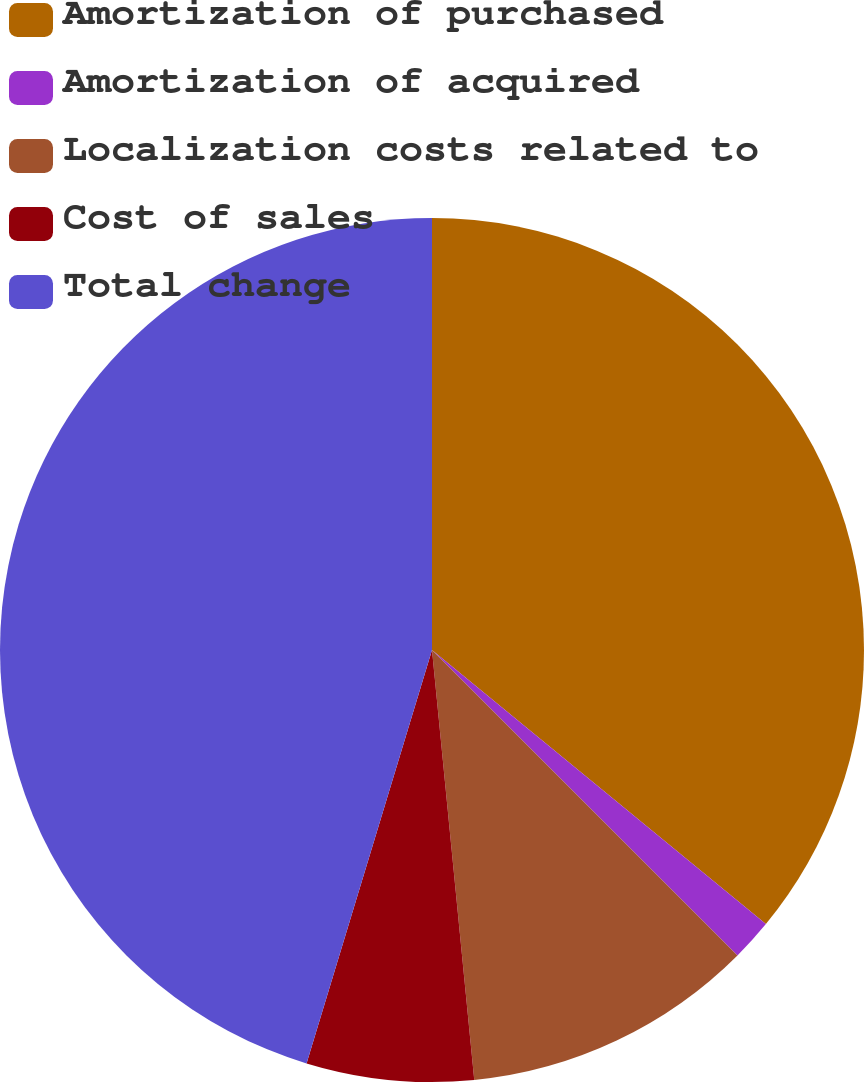Convert chart. <chart><loc_0><loc_0><loc_500><loc_500><pie_chart><fcel>Amortization of purchased<fcel>Amortization of acquired<fcel>Localization costs related to<fcel>Cost of sales<fcel>Total change<nl><fcel>35.94%<fcel>1.56%<fcel>10.94%<fcel>6.25%<fcel>45.31%<nl></chart> 